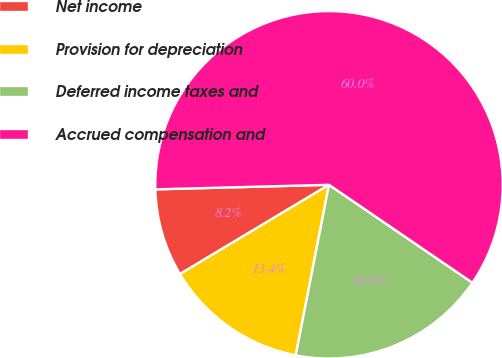Convert chart. <chart><loc_0><loc_0><loc_500><loc_500><pie_chart><fcel>Net income<fcel>Provision for depreciation<fcel>Deferred income taxes and<fcel>Accrued compensation and<nl><fcel>8.17%<fcel>13.35%<fcel>18.53%<fcel>59.95%<nl></chart> 